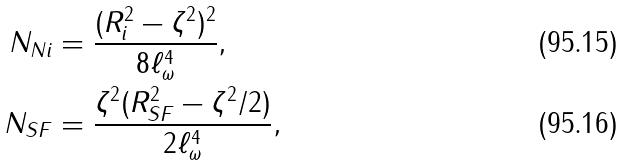Convert formula to latex. <formula><loc_0><loc_0><loc_500><loc_500>N _ { N i } & = \frac { ( R _ { i } ^ { 2 } - \zeta ^ { 2 } ) ^ { 2 } } { 8 \ell _ { \omega } ^ { 4 } } , \\ N _ { S F } & = \frac { \zeta ^ { 2 } ( R _ { S F } ^ { 2 } - \zeta ^ { 2 } / 2 ) } { 2 \ell _ { \omega } ^ { 4 } } ,</formula> 